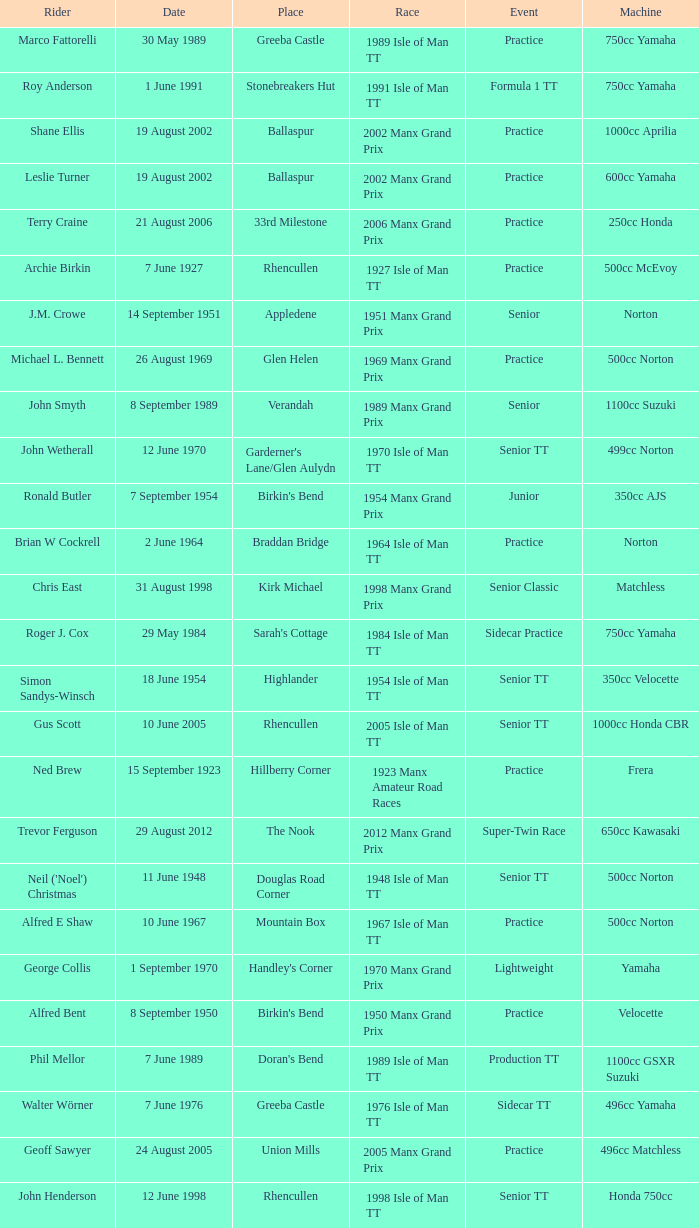What machine did Keith T. Gawler ride? 499cc Norton. 